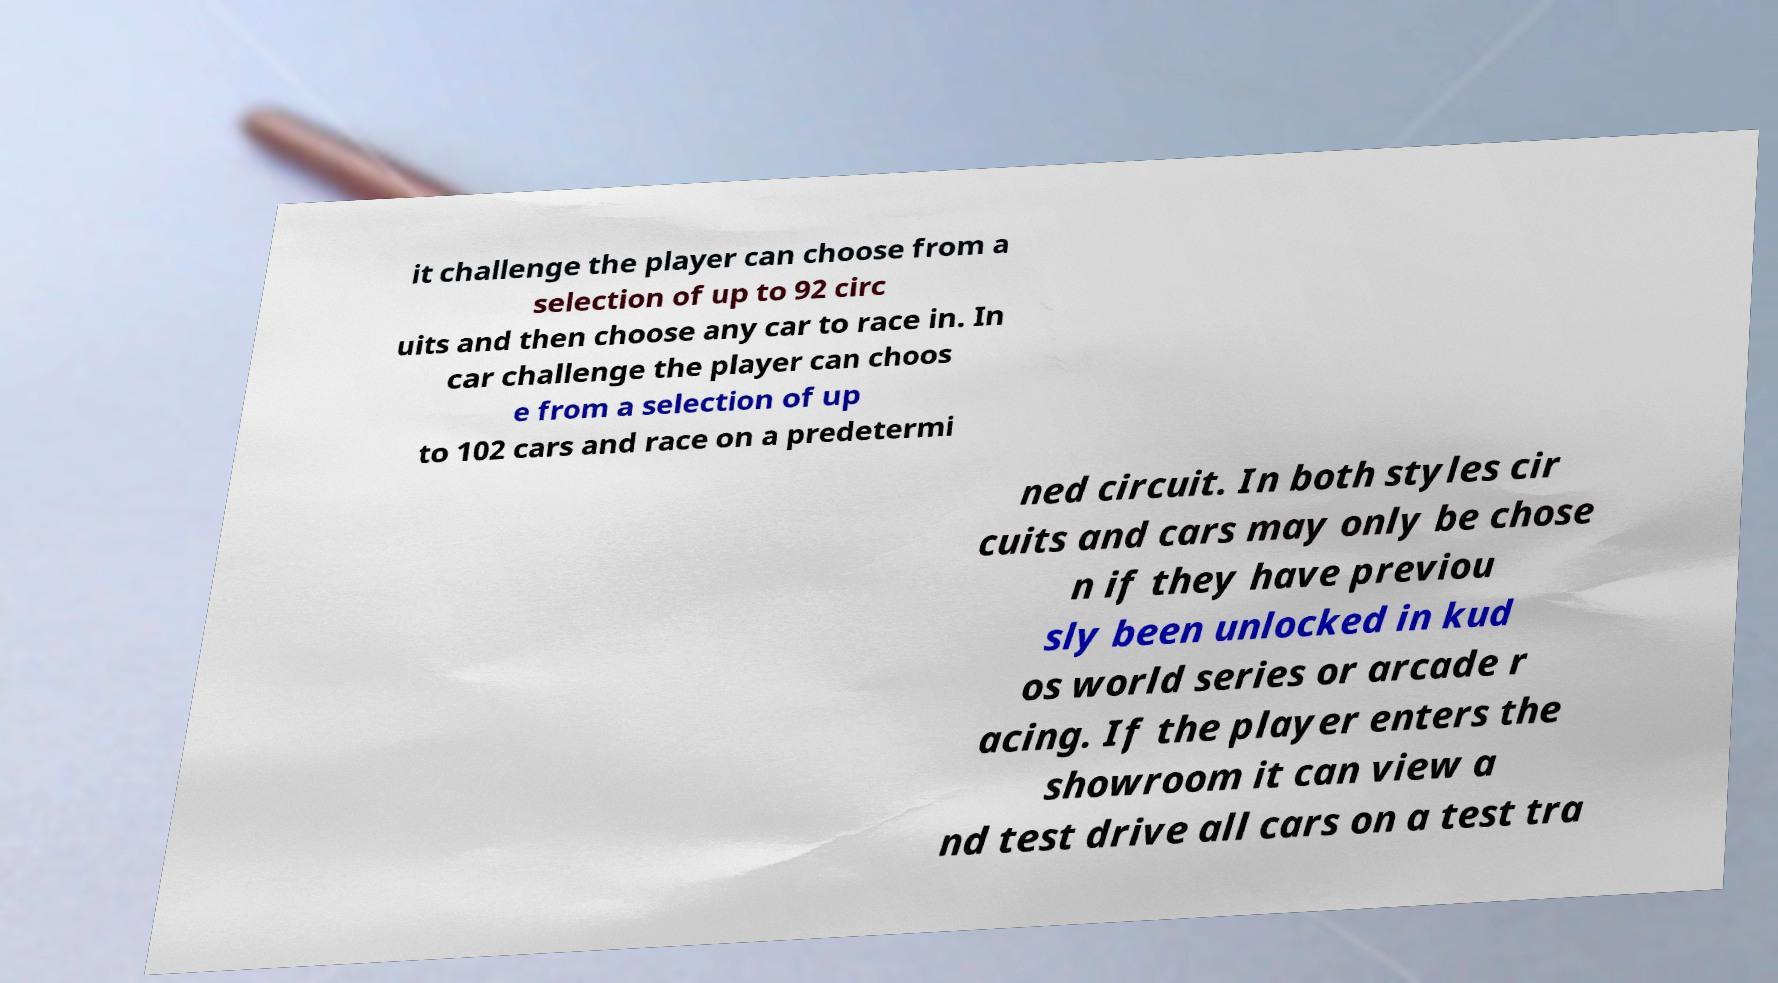Could you assist in decoding the text presented in this image and type it out clearly? it challenge the player can choose from a selection of up to 92 circ uits and then choose any car to race in. In car challenge the player can choos e from a selection of up to 102 cars and race on a predetermi ned circuit. In both styles cir cuits and cars may only be chose n if they have previou sly been unlocked in kud os world series or arcade r acing. If the player enters the showroom it can view a nd test drive all cars on a test tra 